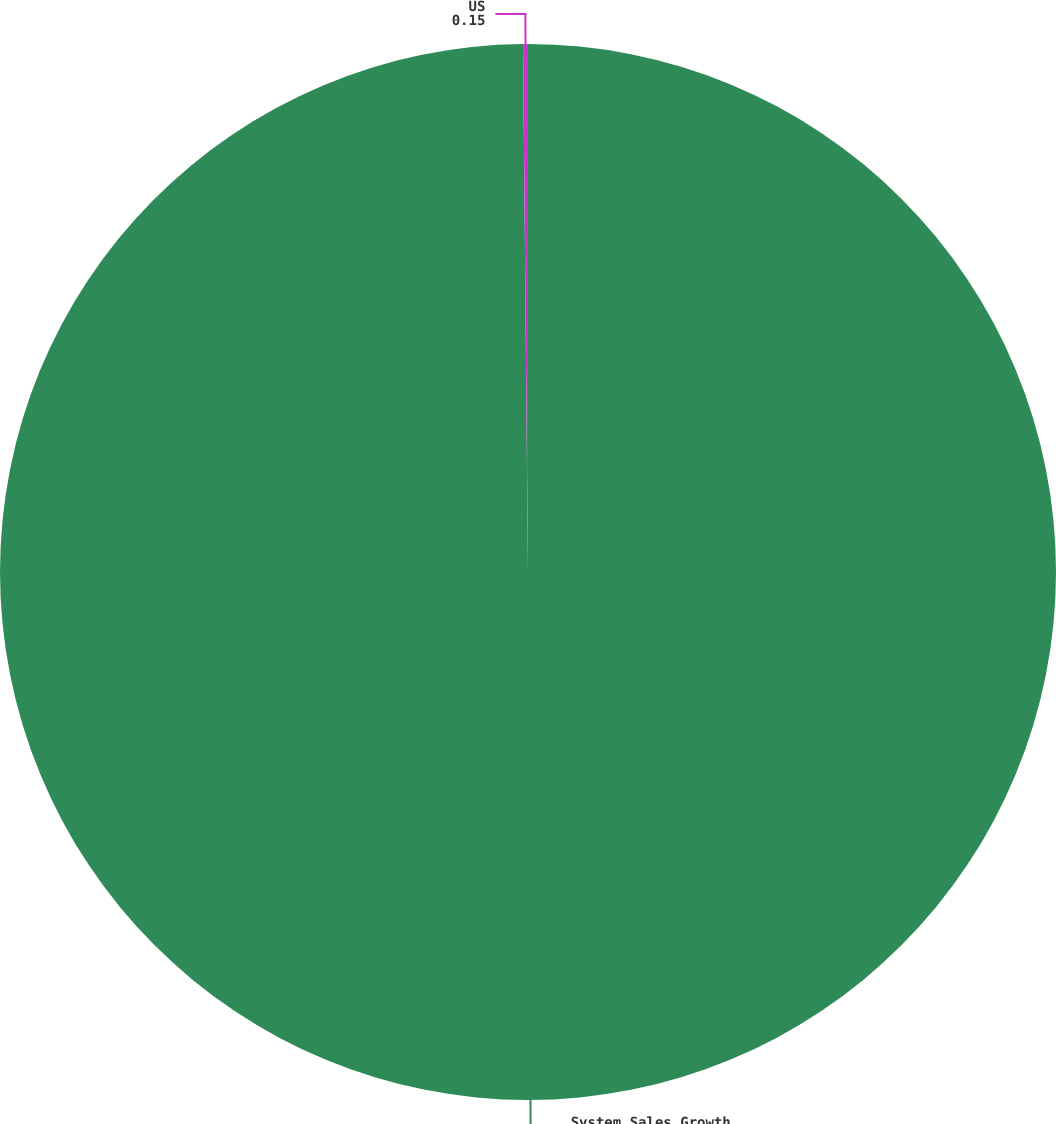Convert chart. <chart><loc_0><loc_0><loc_500><loc_500><pie_chart><fcel>System Sales Growth<fcel>US<nl><fcel>99.85%<fcel>0.15%<nl></chart> 